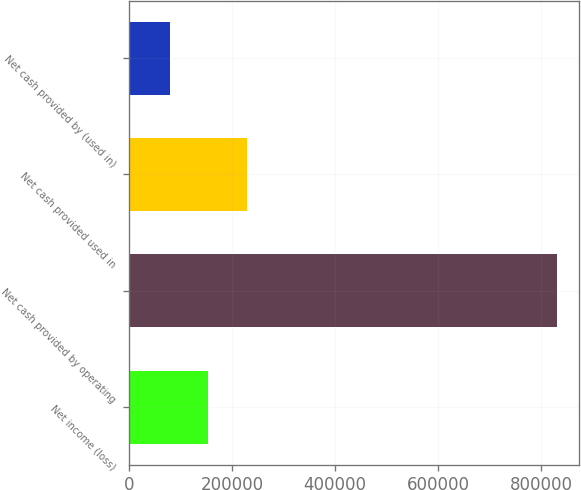Convert chart to OTSL. <chart><loc_0><loc_0><loc_500><loc_500><bar_chart><fcel>Net income (loss)<fcel>Net cash provided by operating<fcel>Net cash provided used in<fcel>Net cash provided by (used in)<nl><fcel>153657<fcel>831209<fcel>228940<fcel>78373<nl></chart> 